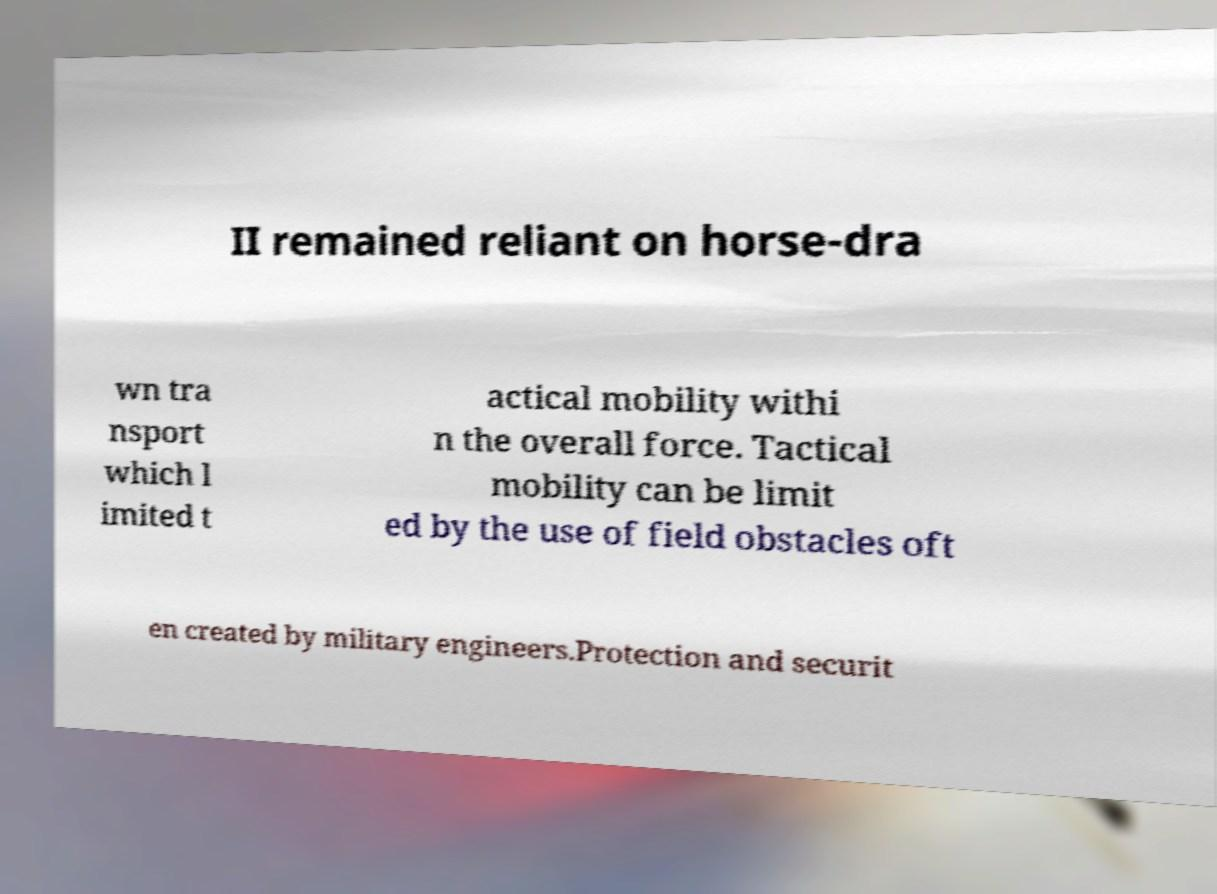Can you accurately transcribe the text from the provided image for me? II remained reliant on horse-dra wn tra nsport which l imited t actical mobility withi n the overall force. Tactical mobility can be limit ed by the use of field obstacles oft en created by military engineers.Protection and securit 